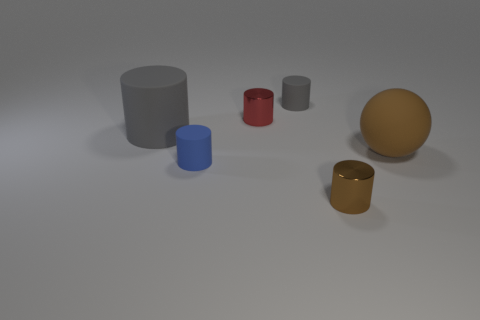There is a small shiny thing that is behind the brown metal cylinder; is it the same shape as the large gray thing that is left of the small brown metal thing?
Provide a succinct answer. Yes. What number of other things are there of the same size as the brown cylinder?
Your response must be concise. 3. What is the size of the brown metal cylinder?
Offer a very short reply. Small. Is the brown object on the left side of the ball made of the same material as the small blue cylinder?
Offer a very short reply. No. What is the color of the big rubber object that is the same shape as the tiny gray object?
Offer a terse response. Gray. There is a shiny object that is in front of the tiny red thing; is it the same color as the rubber sphere?
Your answer should be compact. Yes. Are there any matte objects in front of the big brown thing?
Your response must be concise. Yes. What color is the matte thing that is in front of the big gray cylinder and left of the big brown rubber thing?
Provide a succinct answer. Blue. What shape is the small metallic thing that is the same color as the big sphere?
Provide a succinct answer. Cylinder. There is a shiny cylinder on the left side of the tiny metal cylinder that is in front of the matte ball; how big is it?
Your answer should be compact. Small. 